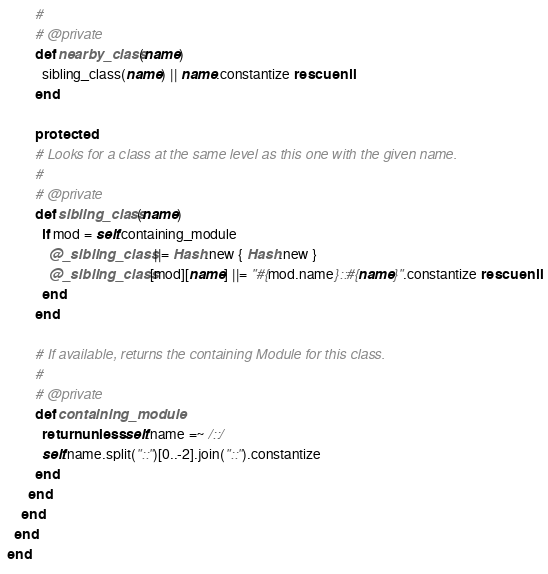<code> <loc_0><loc_0><loc_500><loc_500><_Ruby_>        #
        # @private
        def nearby_class(name)
          sibling_class(name) || name.constantize rescue nil
        end

        protected
        # Looks for a class at the same level as this one with the given name.
        #
        # @private
        def sibling_class(name)
          if mod = self.containing_module
            @_sibling_class ||= Hash.new { Hash.new }
            @_sibling_class[mod][name] ||= "#{mod.name}::#{name}".constantize rescue nil
          end
        end

        # If available, returns the containing Module for this class.
        #
        # @private
        def containing_module
          return unless self.name =~ /::/
          self.name.split("::")[0..-2].join("::").constantize
        end
      end
    end
  end
end
</code> 